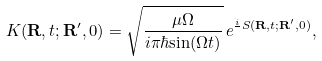<formula> <loc_0><loc_0><loc_500><loc_500>K ( { \mathbf R } , t ; { \mathbf R } ^ { \prime } , 0 ) = \sqrt { \frac { \mu \Omega } { i \pi \hbar { \sin } ( \Omega t ) } } \, e ^ { \frac { i } { } S ( { \mathbf R } , t ; { \mathbf R } ^ { \prime } , 0 ) } ,</formula> 